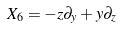Convert formula to latex. <formula><loc_0><loc_0><loc_500><loc_500>X _ { 6 } = - z \partial _ { y } + y \partial _ { z }</formula> 